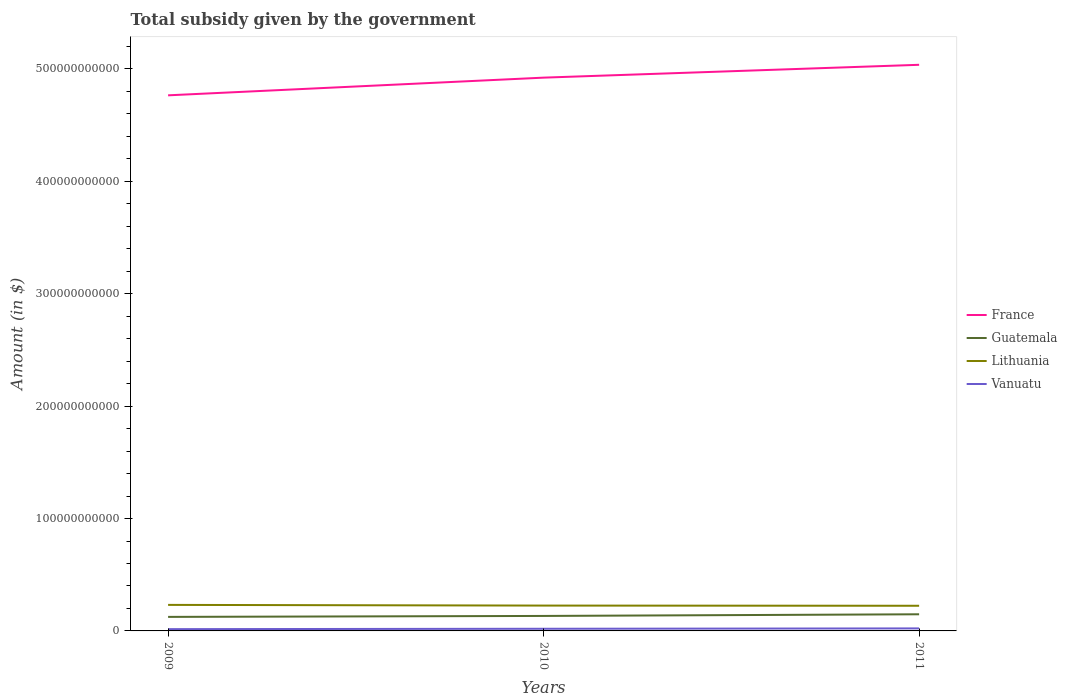Does the line corresponding to Guatemala intersect with the line corresponding to Lithuania?
Make the answer very short. No. Across all years, what is the maximum total revenue collected by the government in Guatemala?
Ensure brevity in your answer.  1.25e+1. What is the total total revenue collected by the government in Guatemala in the graph?
Keep it short and to the point. -2.31e+09. What is the difference between the highest and the second highest total revenue collected by the government in Vanuatu?
Provide a succinct answer. 6.57e+08. Is the total revenue collected by the government in Guatemala strictly greater than the total revenue collected by the government in France over the years?
Offer a terse response. Yes. How many lines are there?
Offer a terse response. 4. How many years are there in the graph?
Make the answer very short. 3. What is the difference between two consecutive major ticks on the Y-axis?
Make the answer very short. 1.00e+11. Are the values on the major ticks of Y-axis written in scientific E-notation?
Your answer should be very brief. No. Does the graph contain any zero values?
Your answer should be very brief. No. Does the graph contain grids?
Keep it short and to the point. No. Where does the legend appear in the graph?
Give a very brief answer. Center right. How are the legend labels stacked?
Offer a very short reply. Vertical. What is the title of the graph?
Ensure brevity in your answer.  Total subsidy given by the government. Does "Aruba" appear as one of the legend labels in the graph?
Ensure brevity in your answer.  No. What is the label or title of the Y-axis?
Provide a succinct answer. Amount (in $). What is the Amount (in $) in France in 2009?
Give a very brief answer. 4.77e+11. What is the Amount (in $) in Guatemala in 2009?
Offer a terse response. 1.25e+1. What is the Amount (in $) of Lithuania in 2009?
Your response must be concise. 2.32e+1. What is the Amount (in $) in Vanuatu in 2009?
Offer a very short reply. 1.59e+09. What is the Amount (in $) of France in 2010?
Make the answer very short. 4.92e+11. What is the Amount (in $) in Guatemala in 2010?
Offer a very short reply. 1.33e+1. What is the Amount (in $) of Lithuania in 2010?
Your response must be concise. 2.26e+1. What is the Amount (in $) in Vanuatu in 2010?
Provide a succinct answer. 1.92e+09. What is the Amount (in $) of France in 2011?
Your answer should be compact. 5.04e+11. What is the Amount (in $) of Guatemala in 2011?
Offer a very short reply. 1.48e+1. What is the Amount (in $) in Lithuania in 2011?
Your answer should be compact. 2.24e+1. What is the Amount (in $) of Vanuatu in 2011?
Give a very brief answer. 2.24e+09. Across all years, what is the maximum Amount (in $) of France?
Your answer should be compact. 5.04e+11. Across all years, what is the maximum Amount (in $) of Guatemala?
Provide a short and direct response. 1.48e+1. Across all years, what is the maximum Amount (in $) of Lithuania?
Your answer should be compact. 2.32e+1. Across all years, what is the maximum Amount (in $) in Vanuatu?
Provide a succinct answer. 2.24e+09. Across all years, what is the minimum Amount (in $) of France?
Ensure brevity in your answer.  4.77e+11. Across all years, what is the minimum Amount (in $) in Guatemala?
Make the answer very short. 1.25e+1. Across all years, what is the minimum Amount (in $) of Lithuania?
Keep it short and to the point. 2.24e+1. Across all years, what is the minimum Amount (in $) in Vanuatu?
Make the answer very short. 1.59e+09. What is the total Amount (in $) in France in the graph?
Keep it short and to the point. 1.47e+12. What is the total Amount (in $) in Guatemala in the graph?
Your answer should be very brief. 4.06e+1. What is the total Amount (in $) in Lithuania in the graph?
Your answer should be compact. 6.81e+1. What is the total Amount (in $) in Vanuatu in the graph?
Your answer should be very brief. 5.75e+09. What is the difference between the Amount (in $) of France in 2009 and that in 2010?
Your response must be concise. -1.57e+1. What is the difference between the Amount (in $) in Guatemala in 2009 and that in 2010?
Keep it short and to the point. -8.47e+08. What is the difference between the Amount (in $) in Lithuania in 2009 and that in 2010?
Offer a terse response. 6.11e+08. What is the difference between the Amount (in $) in Vanuatu in 2009 and that in 2010?
Your response must be concise. -3.33e+08. What is the difference between the Amount (in $) of France in 2009 and that in 2011?
Your response must be concise. -2.72e+1. What is the difference between the Amount (in $) in Guatemala in 2009 and that in 2011?
Provide a succinct answer. -2.31e+09. What is the difference between the Amount (in $) in Lithuania in 2009 and that in 2011?
Provide a short and direct response. 7.80e+08. What is the difference between the Amount (in $) in Vanuatu in 2009 and that in 2011?
Your answer should be compact. -6.57e+08. What is the difference between the Amount (in $) in France in 2010 and that in 2011?
Your answer should be very brief. -1.14e+1. What is the difference between the Amount (in $) of Guatemala in 2010 and that in 2011?
Provide a succinct answer. -1.46e+09. What is the difference between the Amount (in $) of Lithuania in 2010 and that in 2011?
Offer a terse response. 1.69e+08. What is the difference between the Amount (in $) of Vanuatu in 2010 and that in 2011?
Provide a short and direct response. -3.24e+08. What is the difference between the Amount (in $) of France in 2009 and the Amount (in $) of Guatemala in 2010?
Give a very brief answer. 4.63e+11. What is the difference between the Amount (in $) in France in 2009 and the Amount (in $) in Lithuania in 2010?
Provide a short and direct response. 4.54e+11. What is the difference between the Amount (in $) of France in 2009 and the Amount (in $) of Vanuatu in 2010?
Provide a succinct answer. 4.75e+11. What is the difference between the Amount (in $) of Guatemala in 2009 and the Amount (in $) of Lithuania in 2010?
Offer a very short reply. -1.01e+1. What is the difference between the Amount (in $) in Guatemala in 2009 and the Amount (in $) in Vanuatu in 2010?
Your answer should be compact. 1.06e+1. What is the difference between the Amount (in $) of Lithuania in 2009 and the Amount (in $) of Vanuatu in 2010?
Give a very brief answer. 2.12e+1. What is the difference between the Amount (in $) of France in 2009 and the Amount (in $) of Guatemala in 2011?
Provide a short and direct response. 4.62e+11. What is the difference between the Amount (in $) in France in 2009 and the Amount (in $) in Lithuania in 2011?
Make the answer very short. 4.54e+11. What is the difference between the Amount (in $) of France in 2009 and the Amount (in $) of Vanuatu in 2011?
Provide a succinct answer. 4.74e+11. What is the difference between the Amount (in $) of Guatemala in 2009 and the Amount (in $) of Lithuania in 2011?
Give a very brief answer. -9.90e+09. What is the difference between the Amount (in $) of Guatemala in 2009 and the Amount (in $) of Vanuatu in 2011?
Give a very brief answer. 1.02e+1. What is the difference between the Amount (in $) in Lithuania in 2009 and the Amount (in $) in Vanuatu in 2011?
Provide a succinct answer. 2.09e+1. What is the difference between the Amount (in $) of France in 2010 and the Amount (in $) of Guatemala in 2011?
Offer a very short reply. 4.78e+11. What is the difference between the Amount (in $) in France in 2010 and the Amount (in $) in Lithuania in 2011?
Offer a terse response. 4.70e+11. What is the difference between the Amount (in $) in France in 2010 and the Amount (in $) in Vanuatu in 2011?
Your answer should be compact. 4.90e+11. What is the difference between the Amount (in $) of Guatemala in 2010 and the Amount (in $) of Lithuania in 2011?
Offer a terse response. -9.05e+09. What is the difference between the Amount (in $) in Guatemala in 2010 and the Amount (in $) in Vanuatu in 2011?
Provide a succinct answer. 1.11e+1. What is the difference between the Amount (in $) in Lithuania in 2010 and the Amount (in $) in Vanuatu in 2011?
Keep it short and to the point. 2.03e+1. What is the average Amount (in $) of France per year?
Offer a terse response. 4.91e+11. What is the average Amount (in $) in Guatemala per year?
Make the answer very short. 1.35e+1. What is the average Amount (in $) of Lithuania per year?
Your answer should be very brief. 2.27e+1. What is the average Amount (in $) in Vanuatu per year?
Give a very brief answer. 1.92e+09. In the year 2009, what is the difference between the Amount (in $) in France and Amount (in $) in Guatemala?
Your answer should be compact. 4.64e+11. In the year 2009, what is the difference between the Amount (in $) of France and Amount (in $) of Lithuania?
Give a very brief answer. 4.53e+11. In the year 2009, what is the difference between the Amount (in $) in France and Amount (in $) in Vanuatu?
Your response must be concise. 4.75e+11. In the year 2009, what is the difference between the Amount (in $) of Guatemala and Amount (in $) of Lithuania?
Give a very brief answer. -1.07e+1. In the year 2009, what is the difference between the Amount (in $) in Guatemala and Amount (in $) in Vanuatu?
Your response must be concise. 1.09e+1. In the year 2009, what is the difference between the Amount (in $) of Lithuania and Amount (in $) of Vanuatu?
Your response must be concise. 2.16e+1. In the year 2010, what is the difference between the Amount (in $) in France and Amount (in $) in Guatemala?
Ensure brevity in your answer.  4.79e+11. In the year 2010, what is the difference between the Amount (in $) of France and Amount (in $) of Lithuania?
Offer a very short reply. 4.70e+11. In the year 2010, what is the difference between the Amount (in $) of France and Amount (in $) of Vanuatu?
Offer a very short reply. 4.90e+11. In the year 2010, what is the difference between the Amount (in $) in Guatemala and Amount (in $) in Lithuania?
Offer a very short reply. -9.22e+09. In the year 2010, what is the difference between the Amount (in $) of Guatemala and Amount (in $) of Vanuatu?
Provide a short and direct response. 1.14e+1. In the year 2010, what is the difference between the Amount (in $) in Lithuania and Amount (in $) in Vanuatu?
Your answer should be compact. 2.06e+1. In the year 2011, what is the difference between the Amount (in $) in France and Amount (in $) in Guatemala?
Give a very brief answer. 4.89e+11. In the year 2011, what is the difference between the Amount (in $) in France and Amount (in $) in Lithuania?
Ensure brevity in your answer.  4.81e+11. In the year 2011, what is the difference between the Amount (in $) in France and Amount (in $) in Vanuatu?
Provide a short and direct response. 5.01e+11. In the year 2011, what is the difference between the Amount (in $) of Guatemala and Amount (in $) of Lithuania?
Your response must be concise. -7.59e+09. In the year 2011, what is the difference between the Amount (in $) in Guatemala and Amount (in $) in Vanuatu?
Keep it short and to the point. 1.26e+1. In the year 2011, what is the difference between the Amount (in $) in Lithuania and Amount (in $) in Vanuatu?
Ensure brevity in your answer.  2.01e+1. What is the ratio of the Amount (in $) of Guatemala in 2009 to that in 2010?
Make the answer very short. 0.94. What is the ratio of the Amount (in $) in Lithuania in 2009 to that in 2010?
Offer a terse response. 1.03. What is the ratio of the Amount (in $) of Vanuatu in 2009 to that in 2010?
Your answer should be very brief. 0.83. What is the ratio of the Amount (in $) of France in 2009 to that in 2011?
Your response must be concise. 0.95. What is the ratio of the Amount (in $) in Guatemala in 2009 to that in 2011?
Your response must be concise. 0.84. What is the ratio of the Amount (in $) of Lithuania in 2009 to that in 2011?
Offer a very short reply. 1.03. What is the ratio of the Amount (in $) of Vanuatu in 2009 to that in 2011?
Keep it short and to the point. 0.71. What is the ratio of the Amount (in $) in France in 2010 to that in 2011?
Make the answer very short. 0.98. What is the ratio of the Amount (in $) in Guatemala in 2010 to that in 2011?
Your answer should be compact. 0.9. What is the ratio of the Amount (in $) in Lithuania in 2010 to that in 2011?
Ensure brevity in your answer.  1.01. What is the ratio of the Amount (in $) of Vanuatu in 2010 to that in 2011?
Offer a terse response. 0.86. What is the difference between the highest and the second highest Amount (in $) of France?
Make the answer very short. 1.14e+1. What is the difference between the highest and the second highest Amount (in $) in Guatemala?
Give a very brief answer. 1.46e+09. What is the difference between the highest and the second highest Amount (in $) in Lithuania?
Keep it short and to the point. 6.11e+08. What is the difference between the highest and the second highest Amount (in $) in Vanuatu?
Your response must be concise. 3.24e+08. What is the difference between the highest and the lowest Amount (in $) in France?
Keep it short and to the point. 2.72e+1. What is the difference between the highest and the lowest Amount (in $) of Guatemala?
Provide a succinct answer. 2.31e+09. What is the difference between the highest and the lowest Amount (in $) in Lithuania?
Provide a short and direct response. 7.80e+08. What is the difference between the highest and the lowest Amount (in $) of Vanuatu?
Your answer should be very brief. 6.57e+08. 